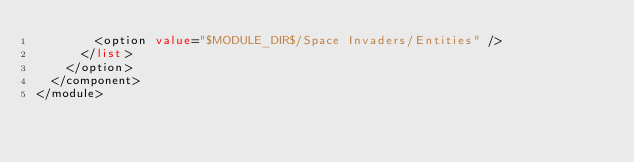<code> <loc_0><loc_0><loc_500><loc_500><_XML_>        <option value="$MODULE_DIR$/Space Invaders/Entities" />
      </list>
    </option>
  </component>
</module></code> 